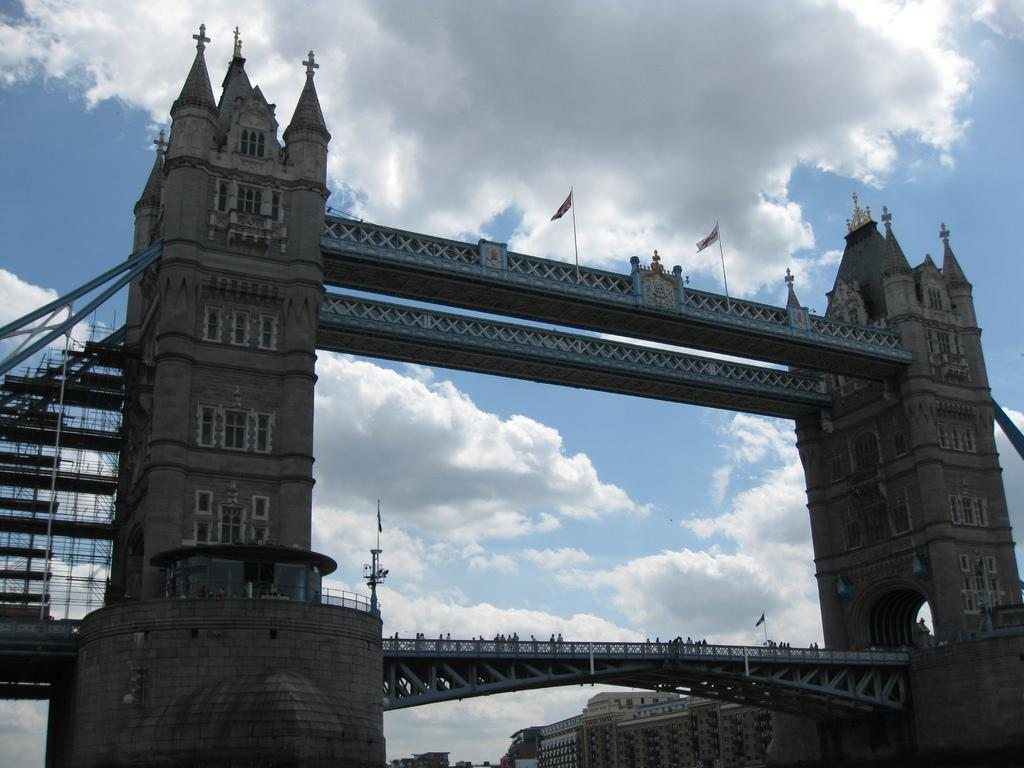What structure is the main subject of the image? There is a bridge in the image. What decorations are on the bridge? There are flags on top of the bridge. Who can be seen near the bridge? There are people behind the railing the railing of the bridge. What can be seen in the background of the image? There is a building and clouds in the background of the image. What is the color of the sky in the image? The sky is blue in the background of the image. What type of scarf is draped over the railing of the bridge in the image? There is no scarf present on the railing of the bridge in the image. What type of yarn is being used to create the flags on the bridge? The image does not provide information about the materials used to create the flags on the bridge. 